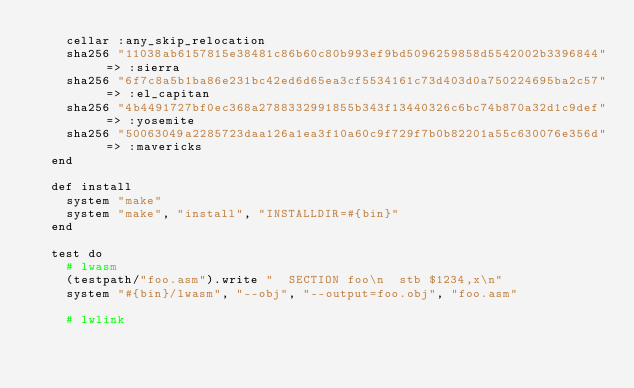<code> <loc_0><loc_0><loc_500><loc_500><_Ruby_>    cellar :any_skip_relocation
    sha256 "11038ab6157815e38481c86b60c80b993ef9bd5096259858d5542002b3396844" => :sierra
    sha256 "6f7c8a5b1ba86e231bc42ed6d65ea3cf5534161c73d403d0a750224695ba2c57" => :el_capitan
    sha256 "4b4491727bf0ec368a2788332991855b343f13440326c6bc74b870a32d1c9def" => :yosemite
    sha256 "50063049a2285723daa126a1ea3f10a60c9f729f7b0b82201a55c630076e356d" => :mavericks
  end

  def install
    system "make"
    system "make", "install", "INSTALLDIR=#{bin}"
  end

  test do
    # lwasm
    (testpath/"foo.asm").write "  SECTION foo\n  stb $1234,x\n"
    system "#{bin}/lwasm", "--obj", "--output=foo.obj", "foo.asm"

    # lwlink</code> 